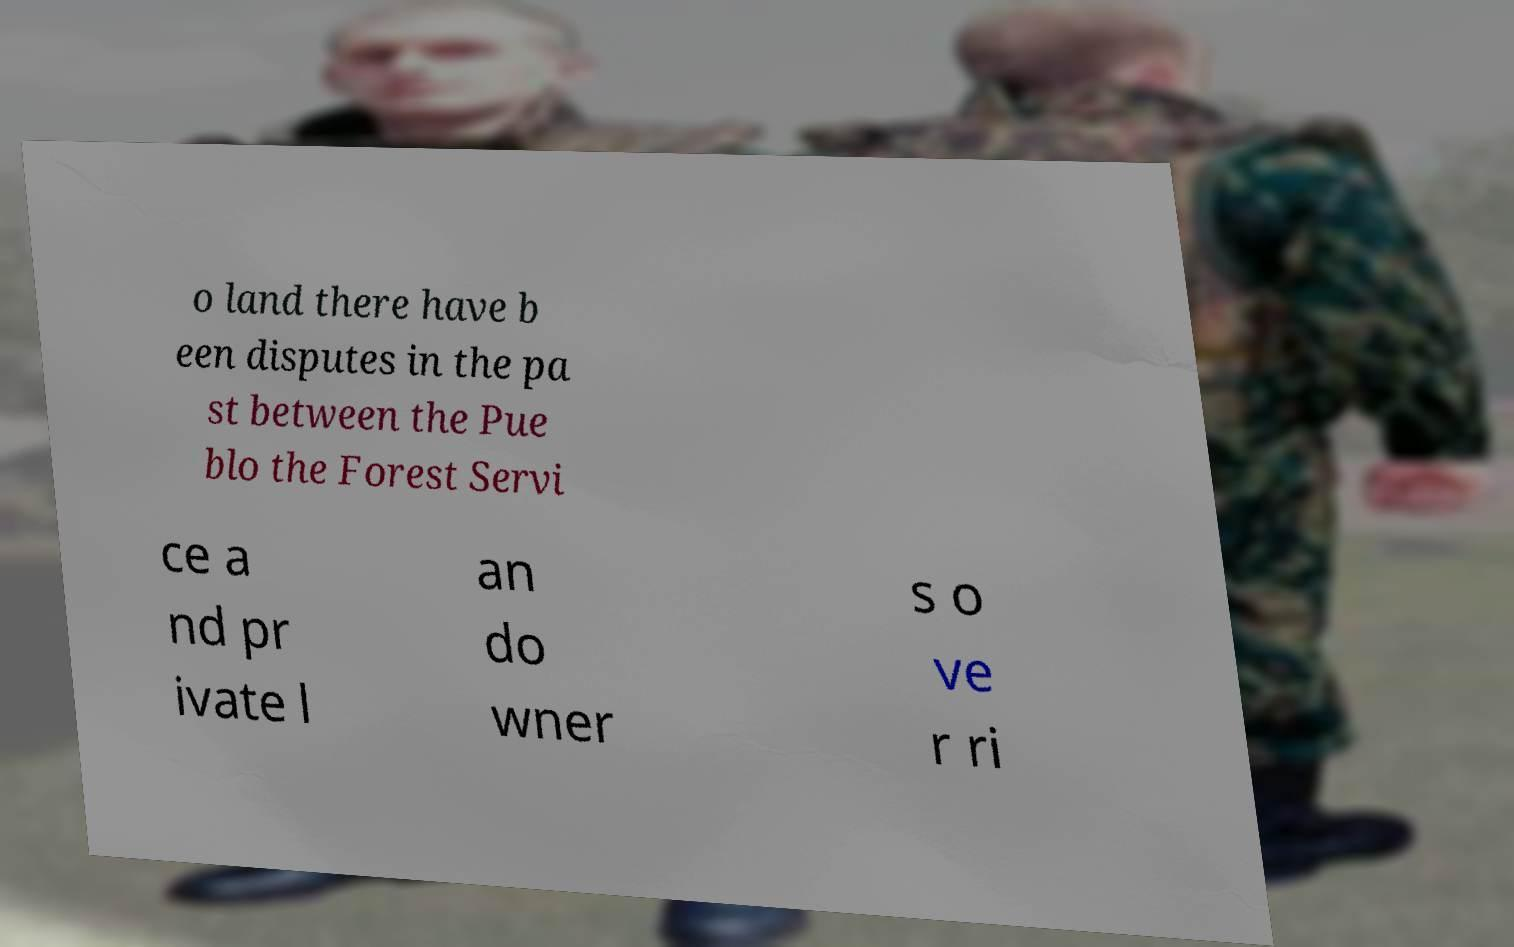What messages or text are displayed in this image? I need them in a readable, typed format. o land there have b een disputes in the pa st between the Pue blo the Forest Servi ce a nd pr ivate l an do wner s o ve r ri 